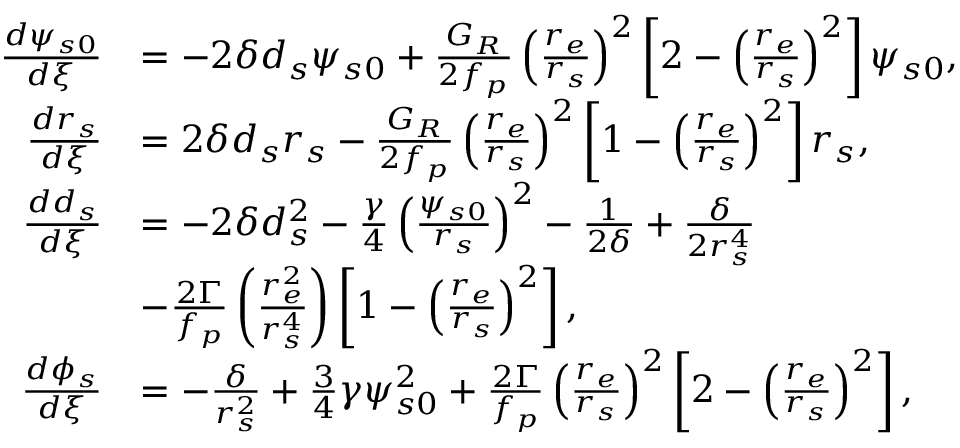Convert formula to latex. <formula><loc_0><loc_0><loc_500><loc_500>\begin{array} { r l } { \frac { d \psi _ { s 0 } } { d \xi } } & { = - 2 \delta d _ { s } \psi _ { s 0 } + \frac { G _ { R } } { 2 f _ { p } } \left ( \frac { r _ { e } } { r _ { s } } \right ) ^ { 2 } \left [ 2 - \left ( \frac { r _ { e } } { r _ { s } } \right ) ^ { 2 } \right ] \psi _ { s 0 } , } \\ { \frac { d r _ { s } } { d \xi } } & { = 2 \delta d _ { s } r _ { s } - \frac { G _ { R } } { 2 f _ { p } } \left ( \frac { r _ { e } } { r _ { s } } \right ) ^ { 2 } \left [ 1 - \left ( \frac { r _ { e } } { r _ { s } } \right ) ^ { 2 } \right ] r _ { s } , } \\ { \frac { d d _ { s } } { d \xi } } & { = - 2 \delta d _ { s } ^ { 2 } - \frac { \gamma } { 4 } \left ( \frac { \psi _ { s 0 } } { r _ { s } } \right ) ^ { 2 } - \frac { 1 } { 2 \delta } + \frac { \delta } { 2 r _ { s } ^ { 4 } } } \\ & { - \frac { 2 \Gamma } { f _ { p } } \left ( \frac { r _ { e } ^ { 2 } } { r _ { s } ^ { 4 } } \right ) \left [ 1 - \left ( \frac { r _ { e } } { r _ { s } } \right ) ^ { 2 } \right ] , } \\ { \frac { d \phi _ { s } } { d \xi } } & { = - \frac { \delta } { r _ { s } ^ { 2 } } + \frac { 3 } { 4 } \gamma \psi _ { s 0 } ^ { 2 } + \frac { 2 \Gamma } { f _ { p } } \left ( \frac { r _ { e } } { r _ { s } } \right ) ^ { 2 } \left [ 2 - \left ( \frac { r _ { e } } { r _ { s } } \right ) ^ { 2 } \right ] , } \end{array}</formula> 